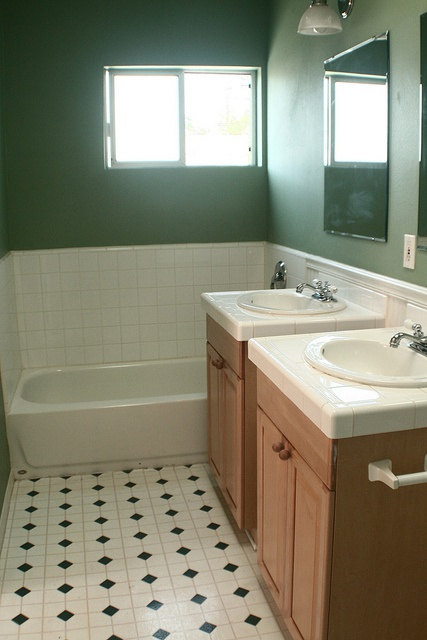Describe the objects in this image and their specific colors. I can see sink in black, beige, and tan tones and sink in black, lightgray, darkgray, and tan tones in this image. 